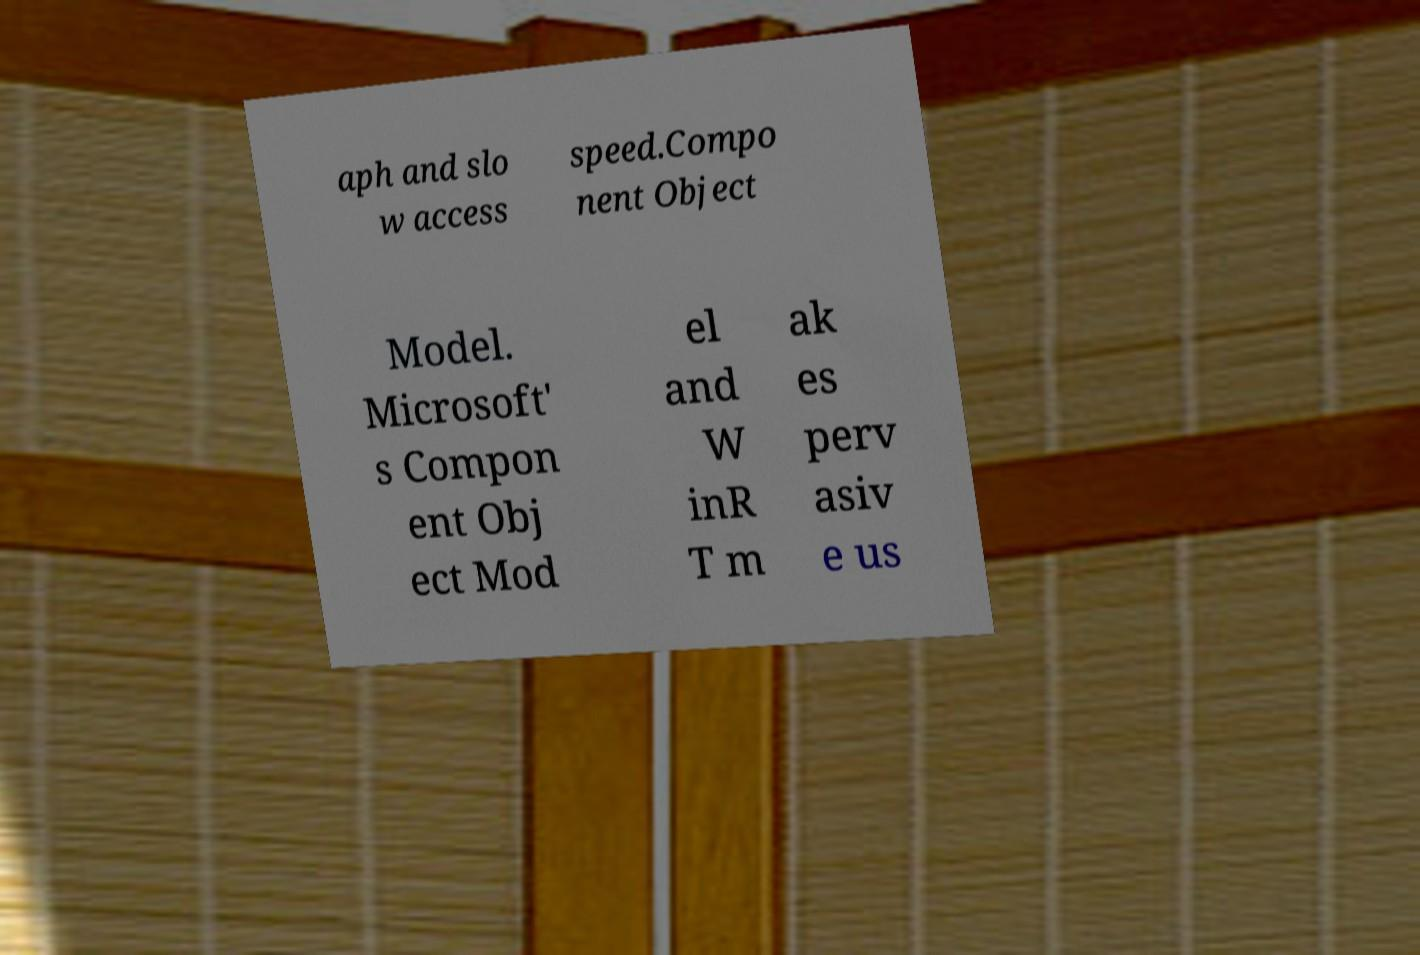What messages or text are displayed in this image? I need them in a readable, typed format. aph and slo w access speed.Compo nent Object Model. Microsoft' s Compon ent Obj ect Mod el and W inR T m ak es perv asiv e us 